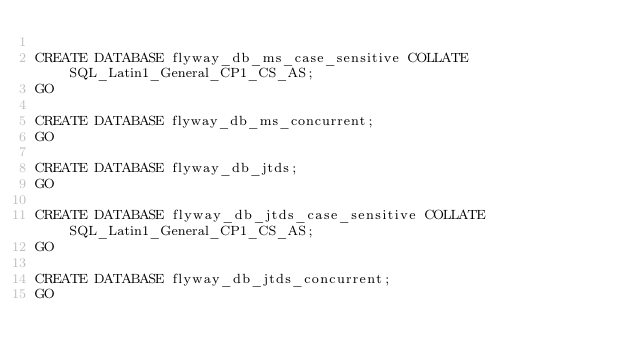<code> <loc_0><loc_0><loc_500><loc_500><_SQL_>
CREATE DATABASE flyway_db_ms_case_sensitive COLLATE SQL_Latin1_General_CP1_CS_AS;
GO

CREATE DATABASE flyway_db_ms_concurrent;
GO

CREATE DATABASE flyway_db_jtds;
GO

CREATE DATABASE flyway_db_jtds_case_sensitive COLLATE SQL_Latin1_General_CP1_CS_AS;
GO

CREATE DATABASE flyway_db_jtds_concurrent;
GO
</code> 